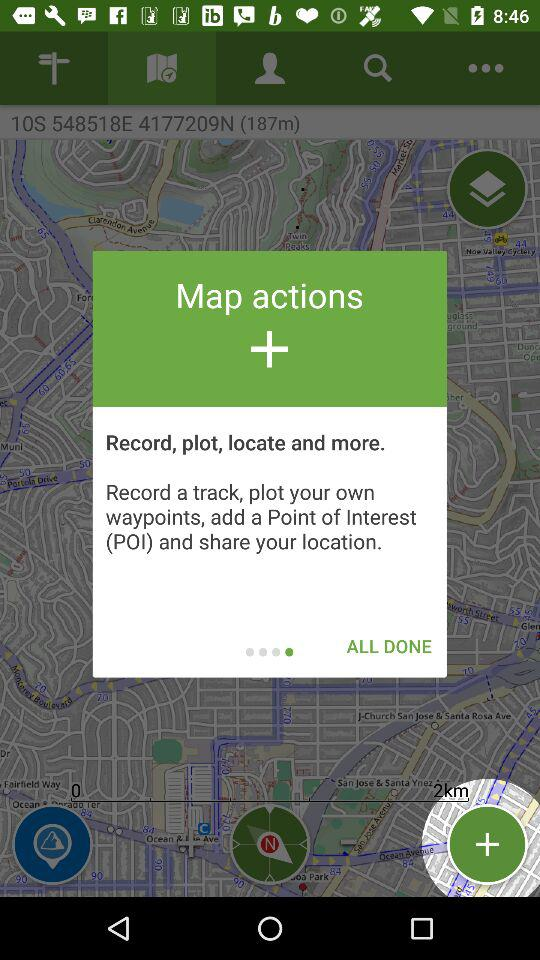How many more ui elements are in the top half of the screen than in the bottom half of the screen?
Answer the question using a single word or phrase. 2 